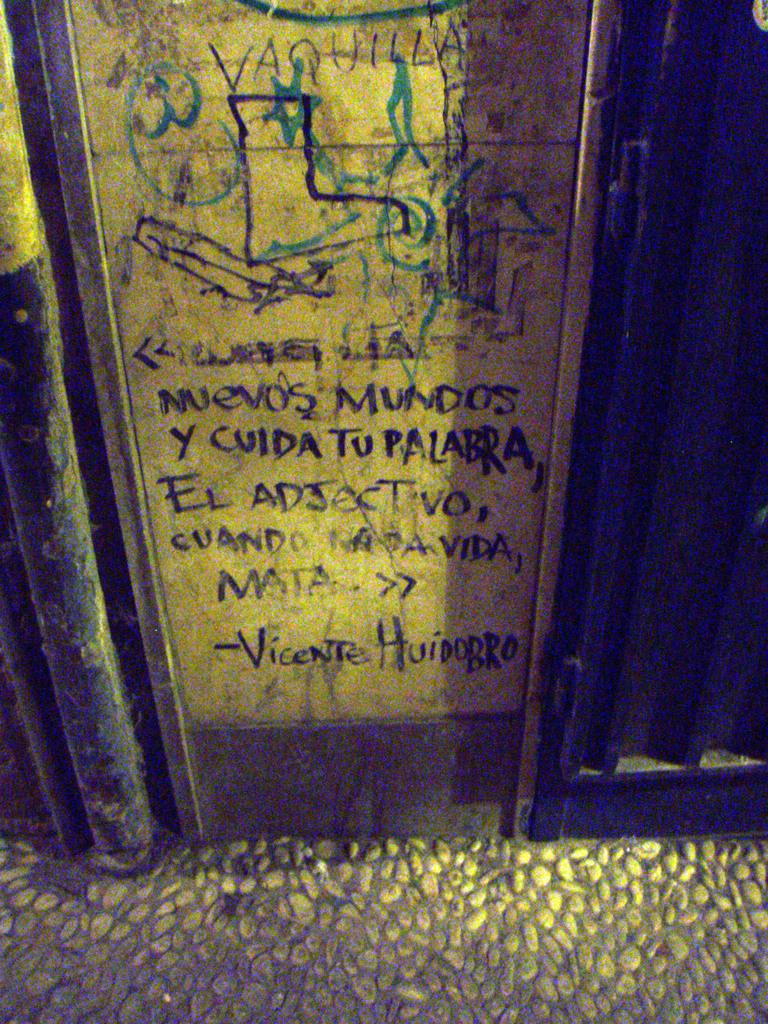What language has been used?
Offer a very short reply. Unanswerable. 